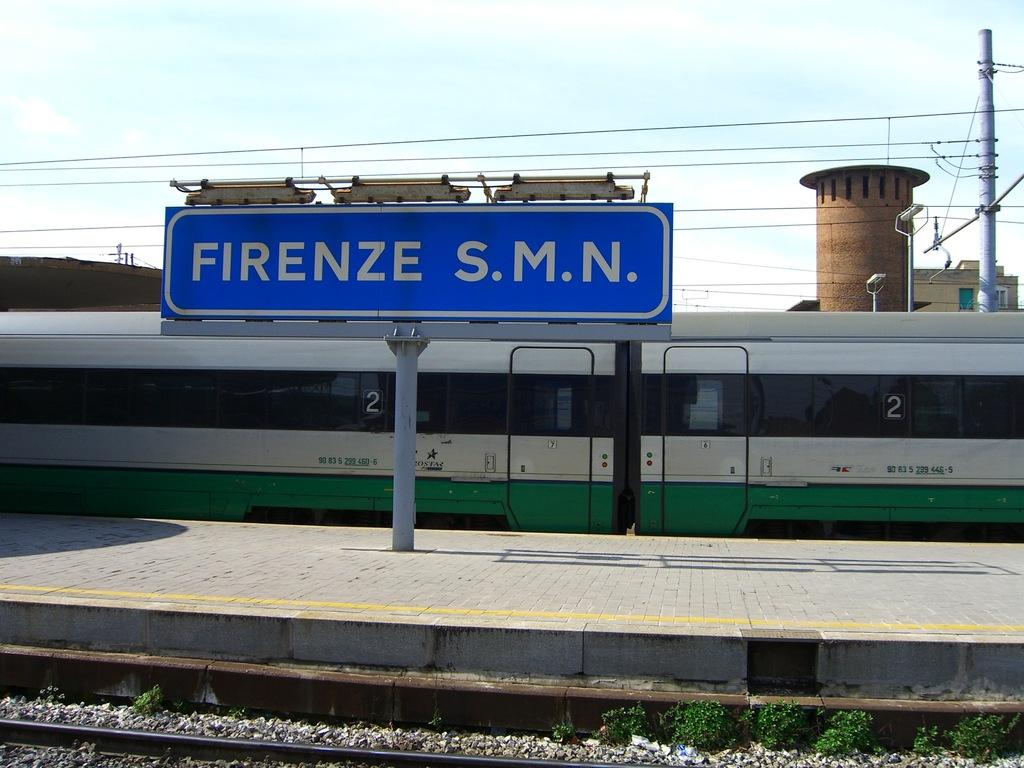What structure can be seen in the foreground of the image? There is a platform in the foreground of the image. What object is attached to a pole in the image? There is a board on a pole in the image. What is located behind the board in the image? A train is visible behind the board. What can be seen in the background of the image? There are poles with wires and the sky visible in the background of the image. Can you tell me how many experts are smiling in the image? There are no experts or smiles present in the image. What type of move is being performed by the train in the image? The train is stationary in the image and not performing any moves. 